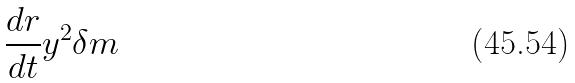Convert formula to latex. <formula><loc_0><loc_0><loc_500><loc_500>\frac { d r } { d t } y ^ { 2 } \delta m</formula> 